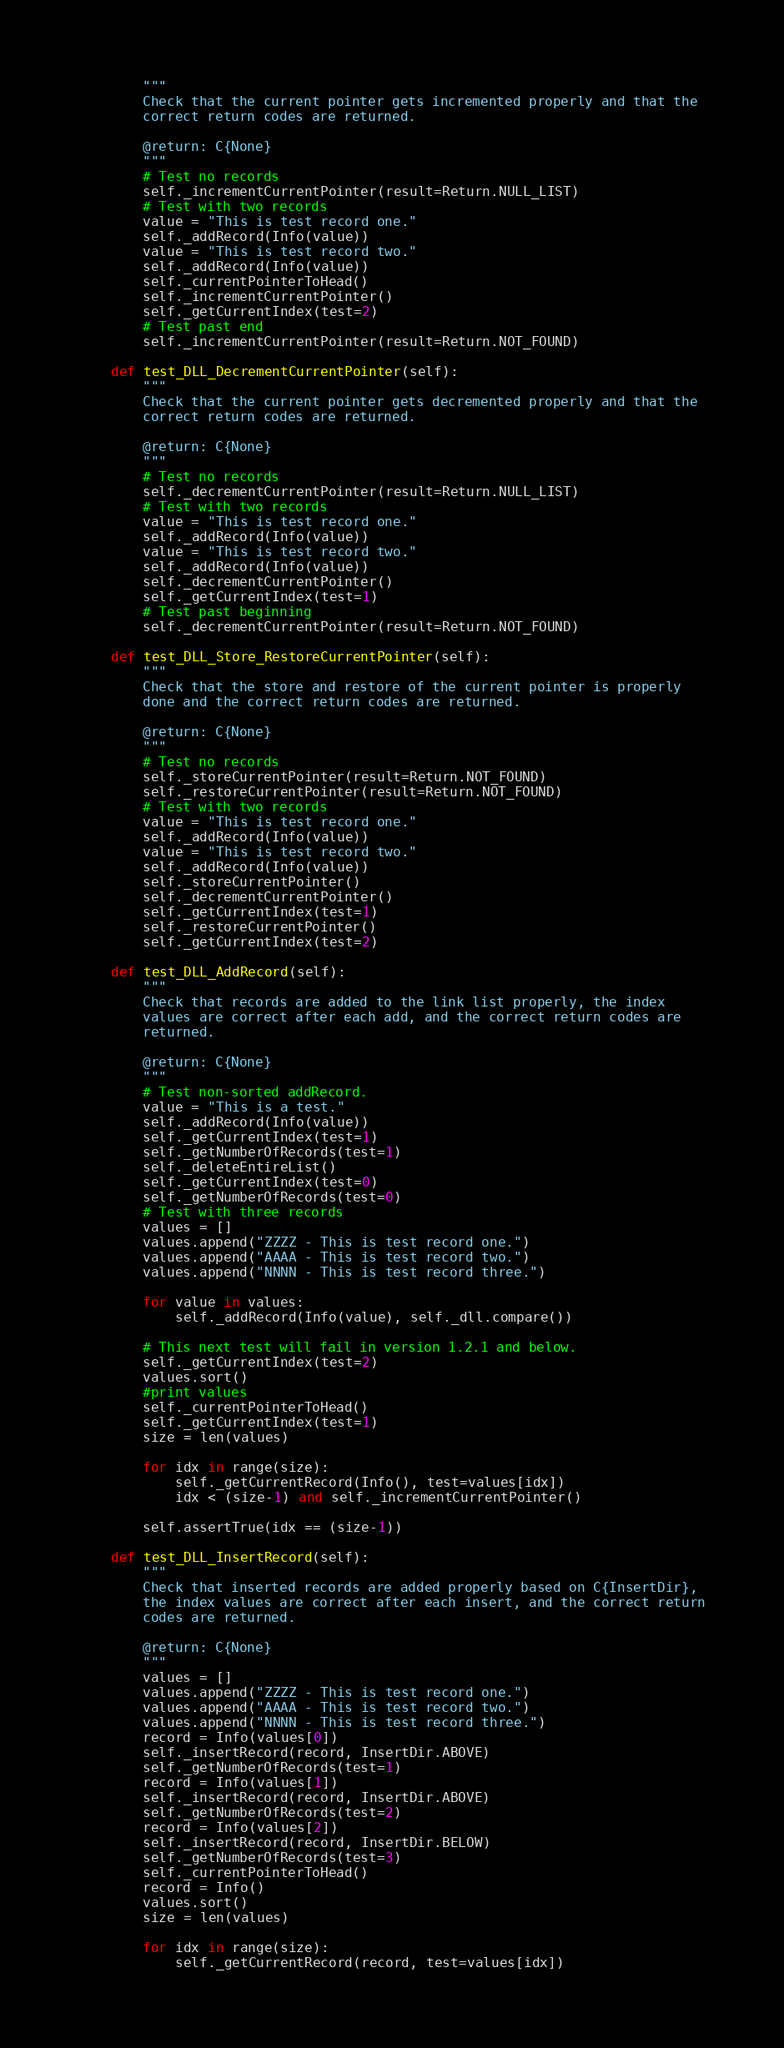Convert code to text. <code><loc_0><loc_0><loc_500><loc_500><_Python_>        """
        Check that the current pointer gets incremented properly and that the
        correct return codes are returned.

        @return: C{None}
        """
        # Test no records
        self._incrementCurrentPointer(result=Return.NULL_LIST)
        # Test with two records
        value = "This is test record one."
        self._addRecord(Info(value))
        value = "This is test record two."
        self._addRecord(Info(value))
        self._currentPointerToHead()
        self._incrementCurrentPointer()
        self._getCurrentIndex(test=2)
        # Test past end
        self._incrementCurrentPointer(result=Return.NOT_FOUND)

    def test_DLL_DecrementCurrentPointer(self):
        """
        Check that the current pointer gets decremented properly and that the
        correct return codes are returned.

        @return: C{None}
        """
        # Test no records
        self._decrementCurrentPointer(result=Return.NULL_LIST)
        # Test with two records
        value = "This is test record one."
        self._addRecord(Info(value))
        value = "This is test record two."
        self._addRecord(Info(value))
        self._decrementCurrentPointer()
        self._getCurrentIndex(test=1)
        # Test past beginning
        self._decrementCurrentPointer(result=Return.NOT_FOUND)

    def test_DLL_Store_RestoreCurrentPointer(self):
        """
        Check that the store and restore of the current pointer is properly
        done and the correct return codes are returned.

        @return: C{None}
        """
        # Test no records
        self._storeCurrentPointer(result=Return.NOT_FOUND)
        self._restoreCurrentPointer(result=Return.NOT_FOUND)
        # Test with two records
        value = "This is test record one."
        self._addRecord(Info(value))
        value = "This is test record two."
        self._addRecord(Info(value))
        self._storeCurrentPointer()
        self._decrementCurrentPointer()
        self._getCurrentIndex(test=1)
        self._restoreCurrentPointer()
        self._getCurrentIndex(test=2)

    def test_DLL_AddRecord(self):
        """
        Check that records are added to the link list properly, the index
        values are correct after each add, and the correct return codes are
        returned.

        @return: C{None}
        """
        # Test non-sorted addRecord.
        value = "This is a test."
        self._addRecord(Info(value))
        self._getCurrentIndex(test=1)
        self._getNumberOfRecords(test=1)
        self._deleteEntireList()
        self._getCurrentIndex(test=0)
        self._getNumberOfRecords(test=0)
        # Test with three records
        values = []
        values.append("ZZZZ - This is test record one.")
        values.append("AAAA - This is test record two.")
        values.append("NNNN - This is test record three.")

        for value in values:
            self._addRecord(Info(value), self._dll.compare())

        # This next test will fail in version 1.2.1 and below.
        self._getCurrentIndex(test=2)
        values.sort()
        #print values
        self._currentPointerToHead()
        self._getCurrentIndex(test=1)
        size = len(values)

        for idx in range(size):
            self._getCurrentRecord(Info(), test=values[idx])
            idx < (size-1) and self._incrementCurrentPointer()

        self.assertTrue(idx == (size-1))

    def test_DLL_InsertRecord(self):
        """
        Check that inserted records are added properly based on C{InsertDir},
        the index values are correct after each insert, and the correct return
        codes are returned.

        @return: C{None}
        """
        values = []
        values.append("ZZZZ - This is test record one.")
        values.append("AAAA - This is test record two.")
        values.append("NNNN - This is test record three.")
        record = Info(values[0])
        self._insertRecord(record, InsertDir.ABOVE)
        self._getNumberOfRecords(test=1)
        record = Info(values[1])
        self._insertRecord(record, InsertDir.ABOVE)
        self._getNumberOfRecords(test=2)
        record = Info(values[2])
        self._insertRecord(record, InsertDir.BELOW)
        self._getNumberOfRecords(test=3)
        self._currentPointerToHead()
        record = Info()
        values.sort()
        size = len(values)

        for idx in range(size):
            self._getCurrentRecord(record, test=values[idx])</code> 